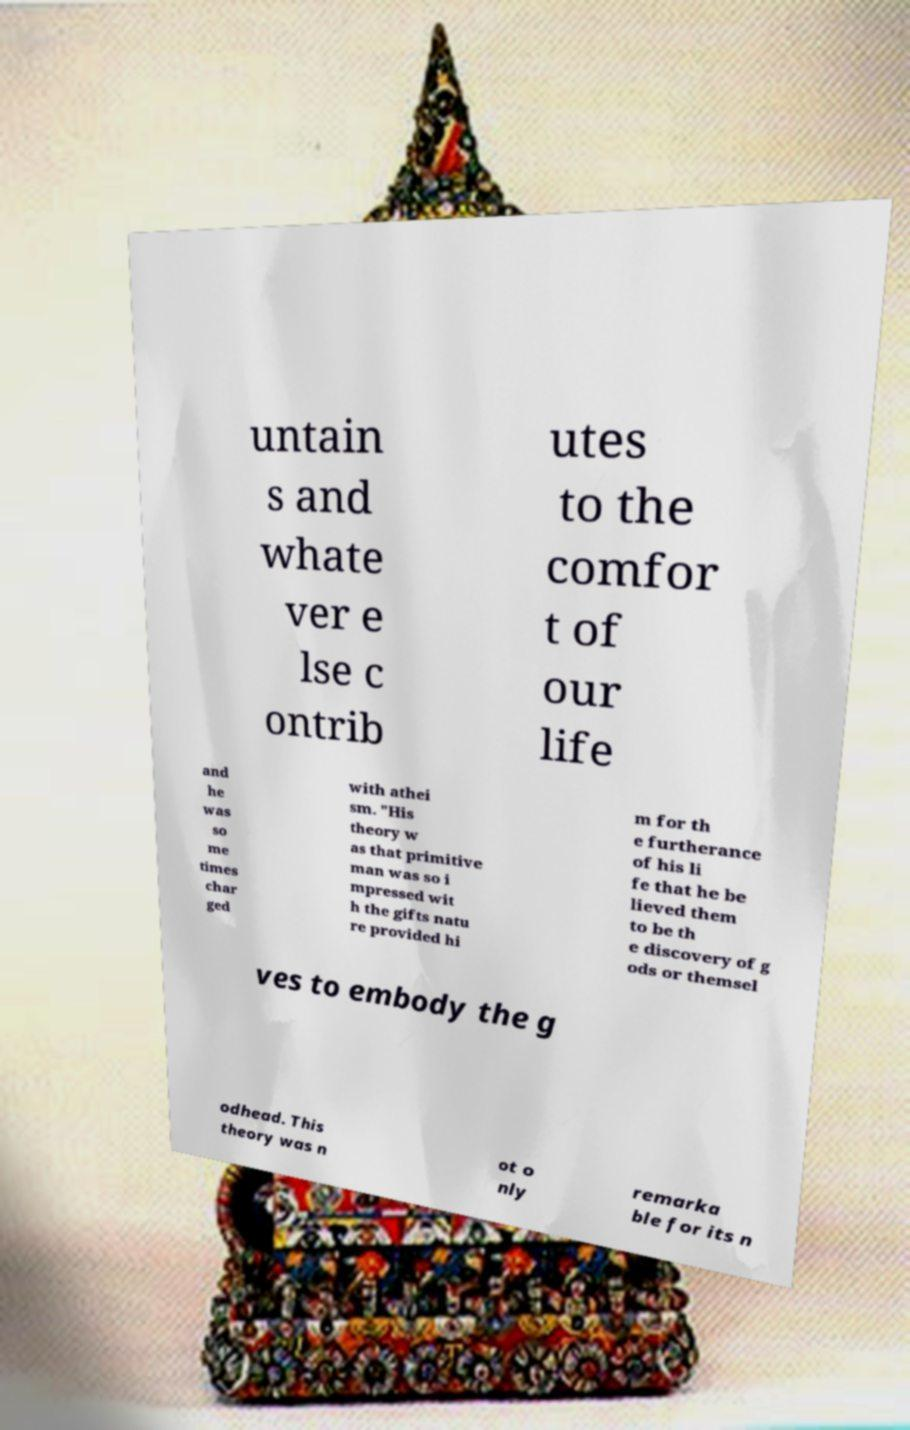What messages or text are displayed in this image? I need them in a readable, typed format. untain s and whate ver e lse c ontrib utes to the comfor t of our life and he was so me times char ged with athei sm. "His theory w as that primitive man was so i mpressed wit h the gifts natu re provided hi m for th e furtherance of his li fe that he be lieved them to be th e discovery of g ods or themsel ves to embody the g odhead. This theory was n ot o nly remarka ble for its n 